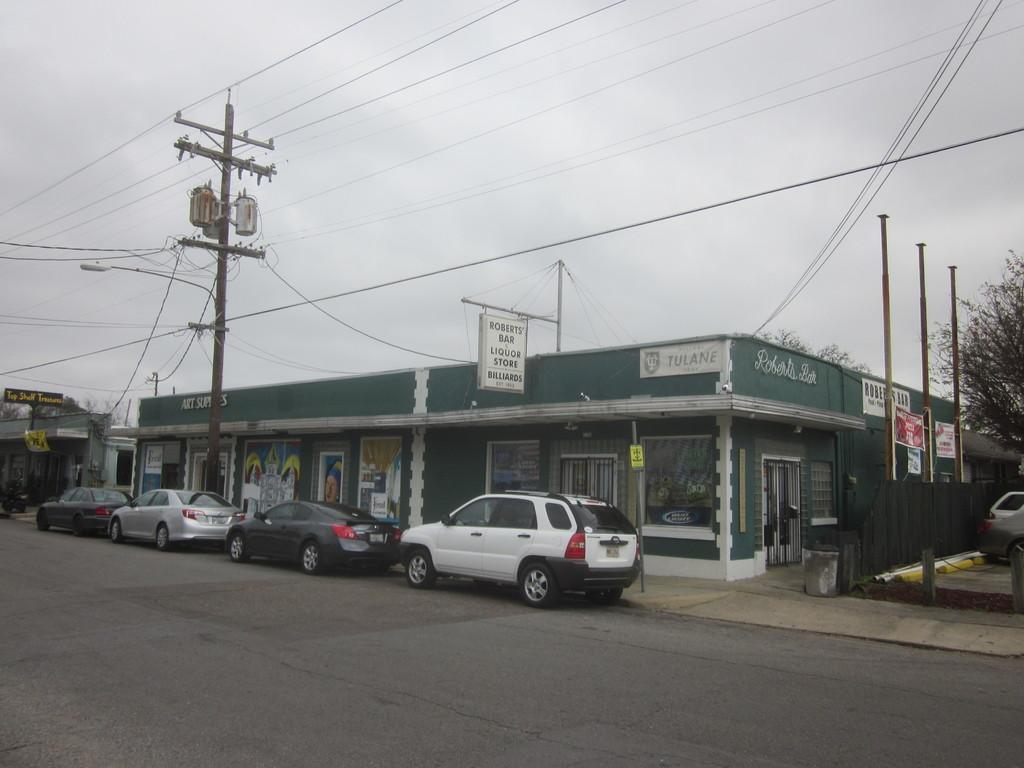What types of man-made structures can be seen in the image? There are vehicles, buildings, poles, and boards with text in the image. What natural elements are present in the image? There are trees and the sky visible in the image. What is the ground like in the image? The ground is visible in the image. What else can be seen in the image besides the structures and natural elements? There are wires in the image. Can you see a knot tied on any of the trees in the image? There is no knot tied on any of the trees in the image. What beliefs are represented by the boards with text in the image? The boards with text in the image do not convey any beliefs; they are simply text on boards. 